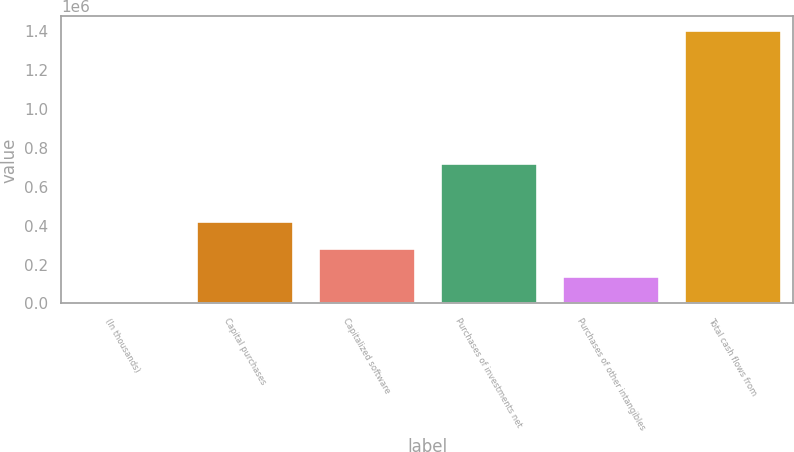<chart> <loc_0><loc_0><loc_500><loc_500><bar_chart><fcel>(In thousands)<fcel>Capital purchases<fcel>Capitalized software<fcel>Purchases of investments net<fcel>Purchases of other intangibles<fcel>Total cash flows from<nl><fcel>2015<fcel>423193<fcel>282801<fcel>720406<fcel>142408<fcel>1.40594e+06<nl></chart> 